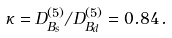<formula> <loc_0><loc_0><loc_500><loc_500>\kappa = D _ { B _ { s } } ^ { ( 5 ) } / D _ { B _ { d } } ^ { ( 5 ) } = 0 . 8 4 \, .</formula> 